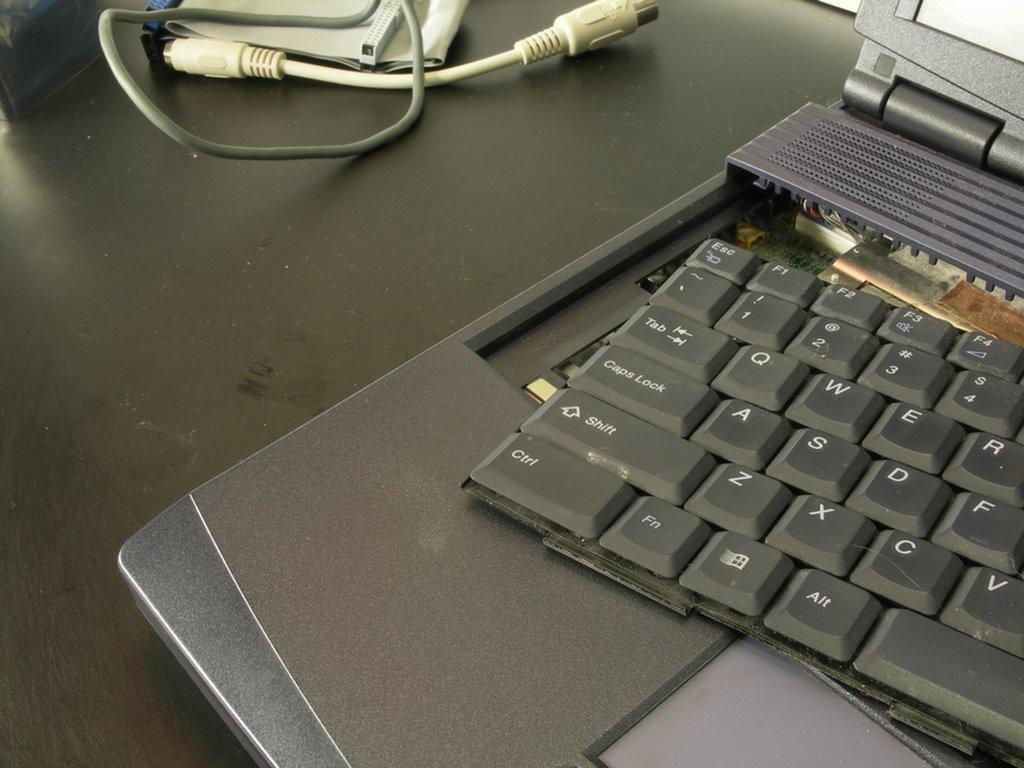Provide a one-sentence caption for the provided image. laptop with keyboard pulled out, ctrl, shift, caps lock and other keys visible. 